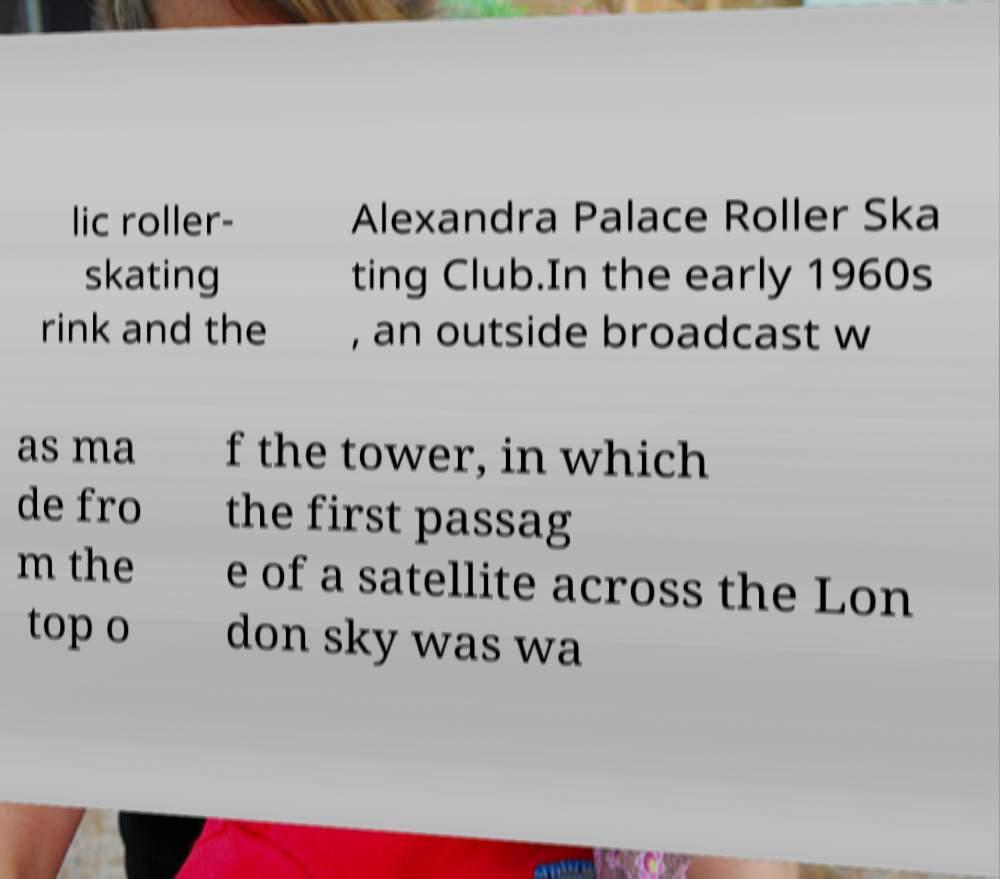Could you extract and type out the text from this image? lic roller- skating rink and the Alexandra Palace Roller Ska ting Club.In the early 1960s , an outside broadcast w as ma de fro m the top o f the tower, in which the first passag e of a satellite across the Lon don sky was wa 